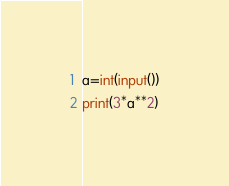Convert code to text. <code><loc_0><loc_0><loc_500><loc_500><_Python_>a=int(input())
print(3*a**2)</code> 